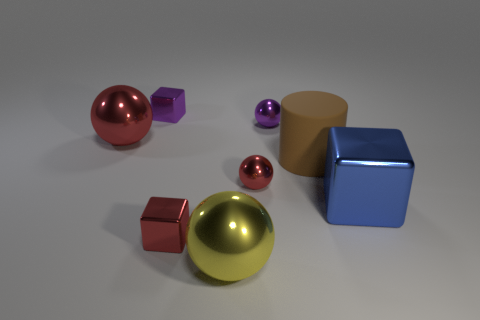Could you speculate on what material these objects might be made of based on their appearance? The objects in the image appear to have a shiny, metallic finish suggesting they could be made of polished metal. However, it's also possible that they are made from a plastic material with a metallic paint finish to give the shiny appearance. 